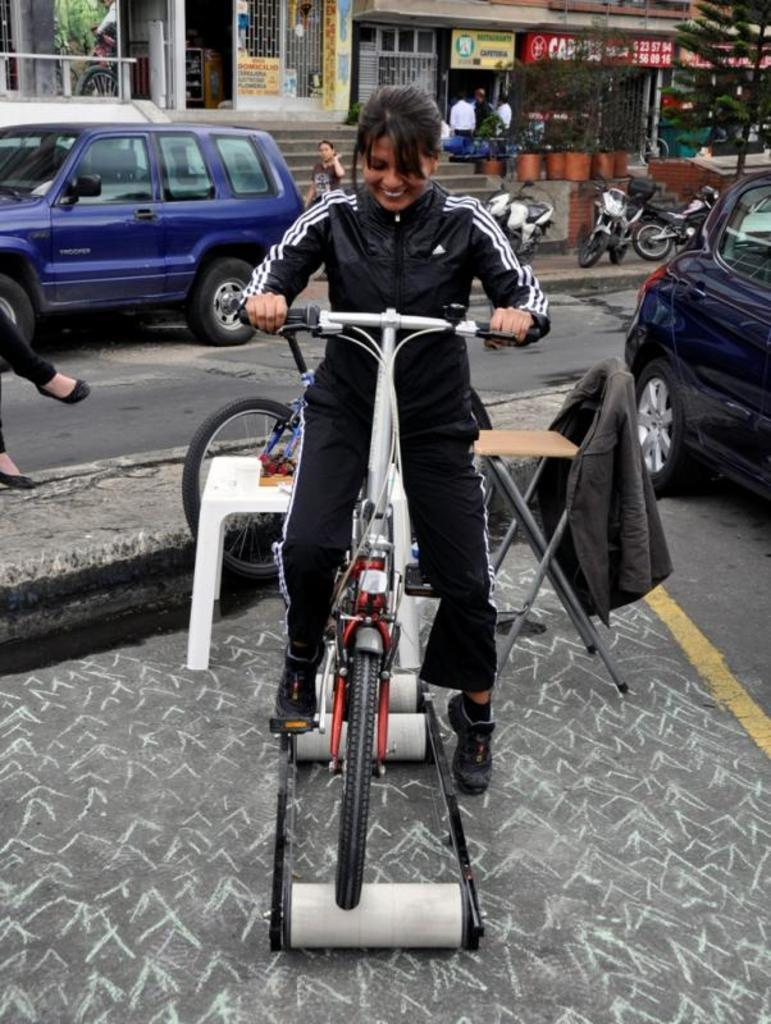Who is the main subject in the image? There is a woman in the image. What is the woman doing in the image? The woman is riding a bicycle. What can be seen in the background of the image? There is a car, bikes, a building, a tree, and persons in the background of the image. What type of leaf can be seen on the woman's bicycle in the image? There are no leaves visible on the woman's bicycle in the image. What is the woman doing while she is sleeping in the image? The woman is not sleeping in the image; she is riding a bicycle. 